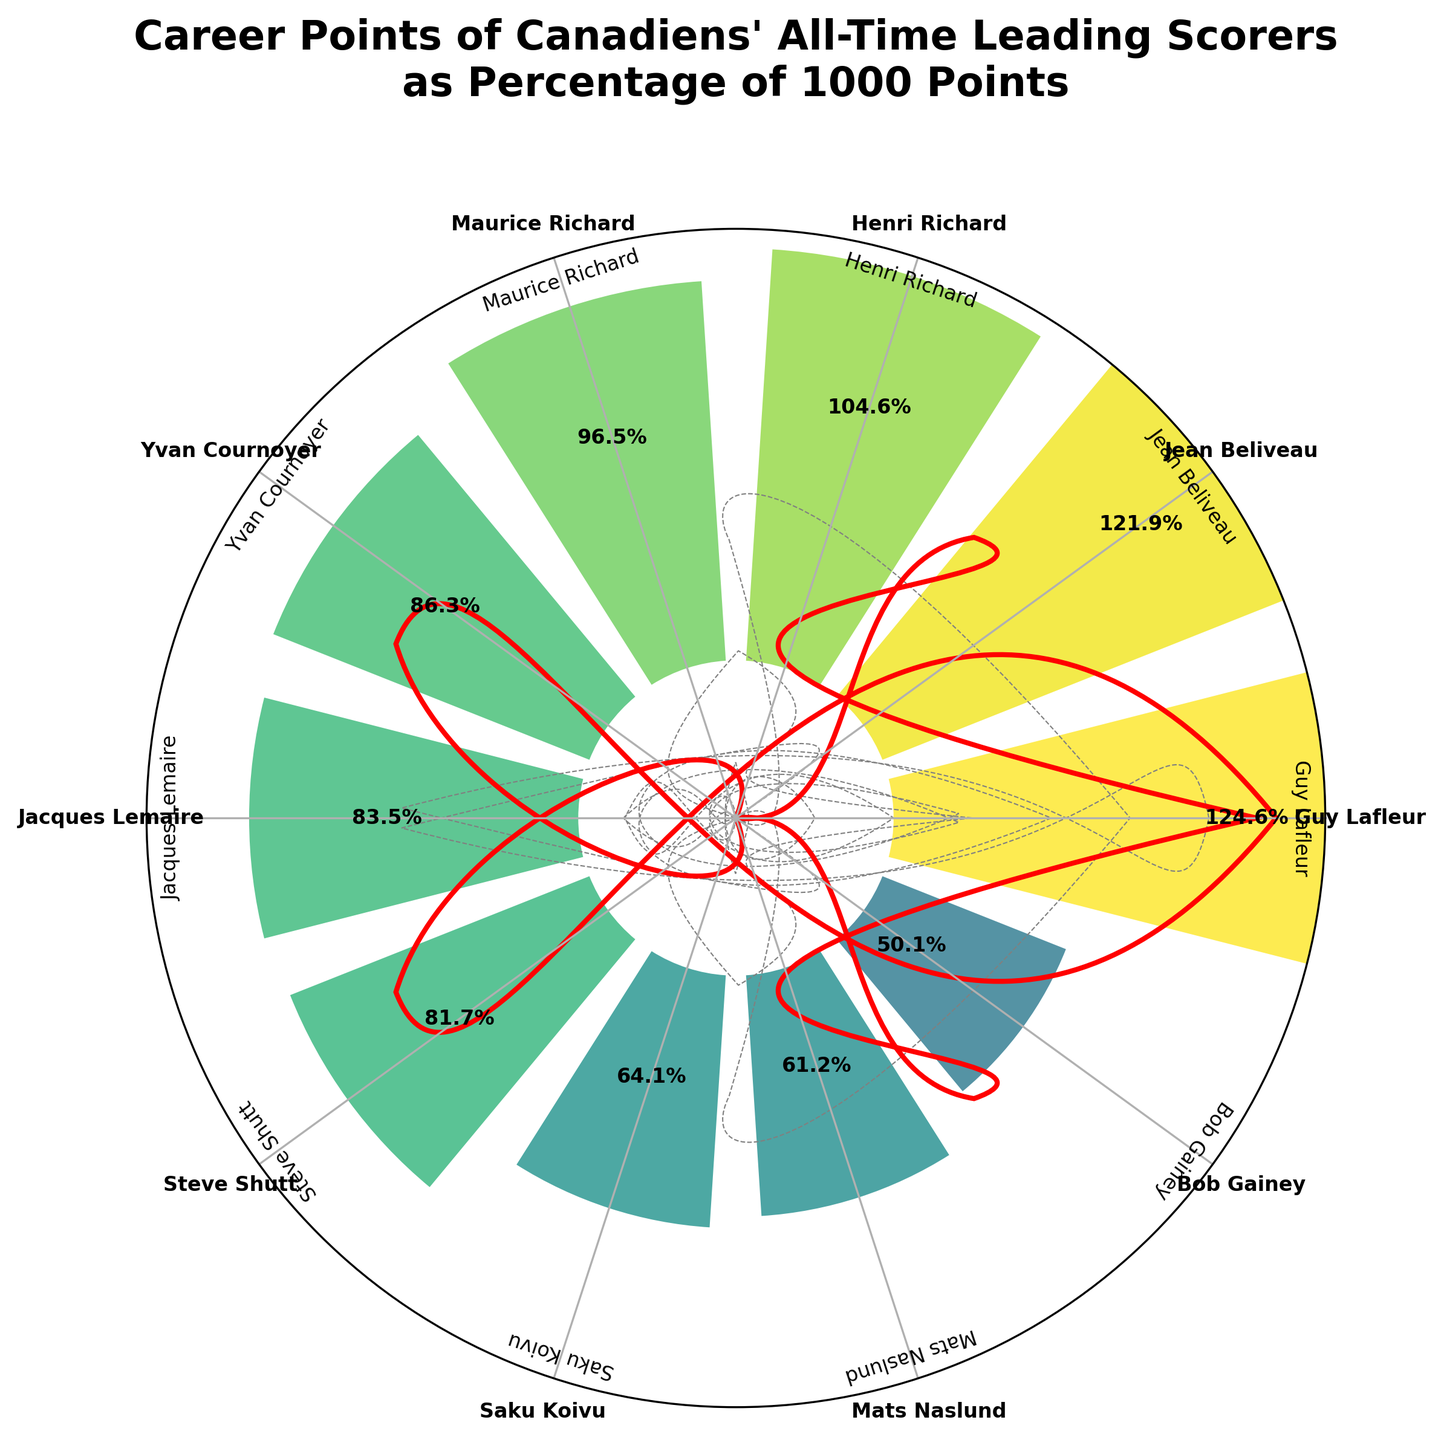What's the title of the chart? The title is located at the top of the chart and reads "Career Points of Canadiens' All-Time Leading Scorers as Percentage of 1000 Points".
Answer: Career Points of Canadiens' All-Time Leading Scorers as Percentage of 1000 Points Which player has the highest percentage of career points? The player with the highest bar in the chart, reaching approximately 124.6%, is Guy Lafleur.
Answer: Guy Lafleur How many players have career points percentages greater than 100%? Observing the chart, we see that three bars exceed the 100% mark: those for Jean Beliveau, Guy Lafleur, and Henri Richard.
Answer: 3 What is the percentage value for Maurice Richard? The percentage value is labeled near the top of Maurice Richard's bar, which is around 96.5%.
Answer: 96.5% Which player has the lowest percentage of career points? The lowest bar, just above 50%, corresponds to Bob Gainey.
Answer: Bob Gainey What is the sum of the percentages for Maurice Richard and Yvan Cournoyer? Maurice Richard's percentage is 96.5% and Yvan Cournoyer's is 86.3%. Adding them together, we get 96.5 + 86.3 = 182.8.
Answer: 182.8 Compare the percentage values for Steve Shutt and Mats Naslund. Who has the higher percentage? The chart shows Steve Shutt at 81.7% and Mats Naslund at 61.2%. Steve Shutt has a higher percentage.
Answer: Steve Shutt What is the average percentage of career points for the top five players? The top five players by percentage are Guy Lafleur (124.6%), Jean Beliveau (121.9%), Henri Richard (104.6%), Maurice Richard (96.5%), and Yvan Cournoyer (86.3%). Their average is (124.6 + 121.9 + 104.6 + 96.5 + 86.3) / 5 = 106.78.
Answer: 106.78 How does the percentage for Saku Koivu compare to that of Jacques Lemaire? Saku Koivu's percentage is 64.1%, while Jacques Lemaire's percentage is 83.5%. Thus, Saku Koivu's percentage is lower.
Answer: Saku Koivu's percentage is lower Which player's percentage is closest to 100% but falls short? Maurice Richard's bar, which is at 96.5%, is the closest to 100% without exceeding it.
Answer: Maurice Richard 